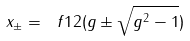Convert formula to latex. <formula><loc_0><loc_0><loc_500><loc_500>x _ { \pm } = \ f { 1 } { 2 } ( g \pm \sqrt { g ^ { 2 } - 1 } )</formula> 